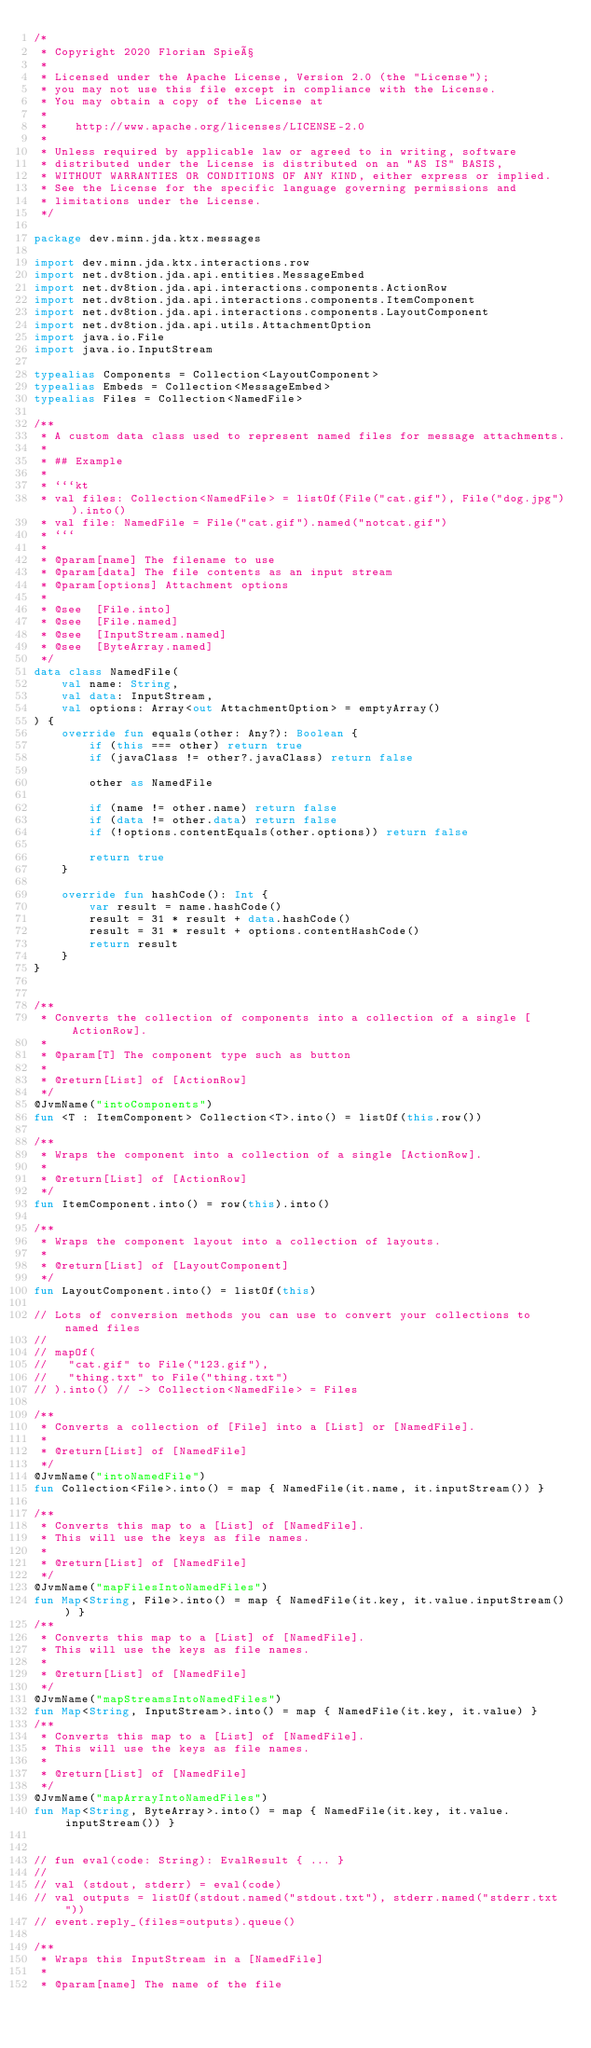Convert code to text. <code><loc_0><loc_0><loc_500><loc_500><_Kotlin_>/*
 * Copyright 2020 Florian Spieß
 *
 * Licensed under the Apache License, Version 2.0 (the "License");
 * you may not use this file except in compliance with the License.
 * You may obtain a copy of the License at
 *
 *    http://www.apache.org/licenses/LICENSE-2.0
 *
 * Unless required by applicable law or agreed to in writing, software
 * distributed under the License is distributed on an "AS IS" BASIS,
 * WITHOUT WARRANTIES OR CONDITIONS OF ANY KIND, either express or implied.
 * See the License for the specific language governing permissions and
 * limitations under the License.
 */

package dev.minn.jda.ktx.messages

import dev.minn.jda.ktx.interactions.row
import net.dv8tion.jda.api.entities.MessageEmbed
import net.dv8tion.jda.api.interactions.components.ActionRow
import net.dv8tion.jda.api.interactions.components.ItemComponent
import net.dv8tion.jda.api.interactions.components.LayoutComponent
import net.dv8tion.jda.api.utils.AttachmentOption
import java.io.File
import java.io.InputStream

typealias Components = Collection<LayoutComponent>
typealias Embeds = Collection<MessageEmbed>
typealias Files = Collection<NamedFile>

/**
 * A custom data class used to represent named files for message attachments.
 *
 * ## Example
 *
 * ```kt
 * val files: Collection<NamedFile> = listOf(File("cat.gif"), File("dog.jpg")).into()
 * val file: NamedFile = File("cat.gif").named("notcat.gif")
 * ```
 *
 * @param[name] The filename to use
 * @param[data] The file contents as an input stream
 * @param[options] Attachment options
 *
 * @see  [File.into]
 * @see  [File.named]
 * @see  [InputStream.named]
 * @see  [ByteArray.named]
 */
data class NamedFile(
    val name: String,
    val data: InputStream,
    val options: Array<out AttachmentOption> = emptyArray()
) {
    override fun equals(other: Any?): Boolean {
        if (this === other) return true
        if (javaClass != other?.javaClass) return false

        other as NamedFile

        if (name != other.name) return false
        if (data != other.data) return false
        if (!options.contentEquals(other.options)) return false

        return true
    }

    override fun hashCode(): Int {
        var result = name.hashCode()
        result = 31 * result + data.hashCode()
        result = 31 * result + options.contentHashCode()
        return result
    }
}


/**
 * Converts the collection of components into a collection of a single [ActionRow].
 *
 * @param[T] The component type such as button
 *
 * @return[List] of [ActionRow]
 */
@JvmName("intoComponents")
fun <T : ItemComponent> Collection<T>.into() = listOf(this.row())

/**
 * Wraps the component into a collection of a single [ActionRow].
 *
 * @return[List] of [ActionRow]
 */
fun ItemComponent.into() = row(this).into()

/**
 * Wraps the component layout into a collection of layouts.
 *
 * @return[List] of [LayoutComponent]
 */
fun LayoutComponent.into() = listOf(this)

// Lots of conversion methods you can use to convert your collections to named files
//
// mapOf(
//   "cat.gif" to File("123.gif"),
//   "thing.txt" to File("thing.txt")
// ).into() // -> Collection<NamedFile> = Files

/**
 * Converts a collection of [File] into a [List] or [NamedFile].
 *
 * @return[List] of [NamedFile]
 */
@JvmName("intoNamedFile")
fun Collection<File>.into() = map { NamedFile(it.name, it.inputStream()) }

/**
 * Converts this map to a [List] of [NamedFile].
 * This will use the keys as file names.
 *
 * @return[List] of [NamedFile]
 */
@JvmName("mapFilesIntoNamedFiles")
fun Map<String, File>.into() = map { NamedFile(it.key, it.value.inputStream()) }
/**
 * Converts this map to a [List] of [NamedFile].
 * This will use the keys as file names.
 *
 * @return[List] of [NamedFile]
 */
@JvmName("mapStreamsIntoNamedFiles")
fun Map<String, InputStream>.into() = map { NamedFile(it.key, it.value) }
/**
 * Converts this map to a [List] of [NamedFile].
 * This will use the keys as file names.
 *
 * @return[List] of [NamedFile]
 */
@JvmName("mapArrayIntoNamedFiles")
fun Map<String, ByteArray>.into() = map { NamedFile(it.key, it.value.inputStream()) }


// fun eval(code: String): EvalResult { ... }
//
// val (stdout, stderr) = eval(code)
// val outputs = listOf(stdout.named("stdout.txt"), stderr.named("stderr.txt"))
// event.reply_(files=outputs).queue()

/**
 * Wraps this InputStream in a [NamedFile]
 *
 * @param[name] The name of the file</code> 